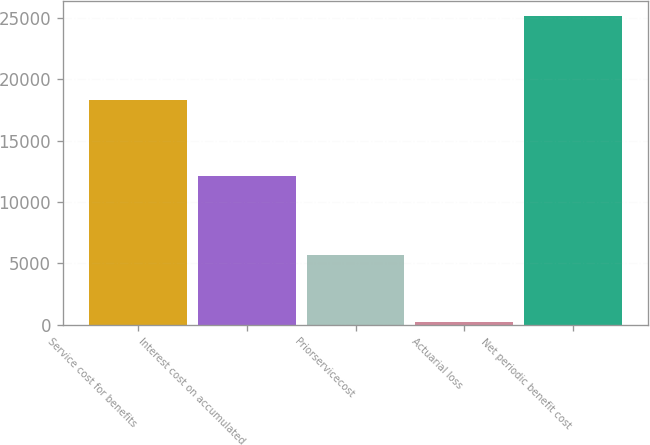<chart> <loc_0><loc_0><loc_500><loc_500><bar_chart><fcel>Service cost for benefits<fcel>Interest cost on accumulated<fcel>Priorservicecost<fcel>Actuarial loss<fcel>Net periodic benefit cost<nl><fcel>18315<fcel>12091<fcel>5685<fcel>247<fcel>25131<nl></chart> 